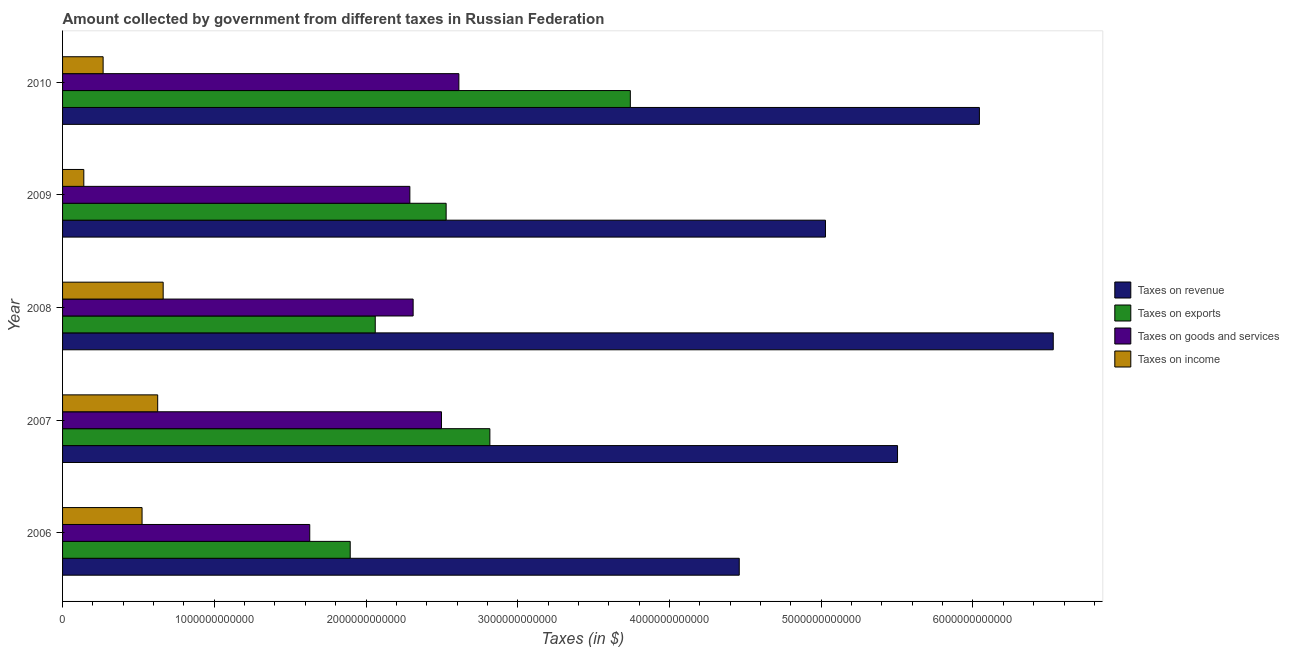How many bars are there on the 2nd tick from the top?
Provide a short and direct response. 4. In how many cases, is the number of bars for a given year not equal to the number of legend labels?
Make the answer very short. 0. What is the amount collected as tax on goods in 2009?
Make the answer very short. 2.29e+12. Across all years, what is the maximum amount collected as tax on income?
Your answer should be compact. 6.63e+11. Across all years, what is the minimum amount collected as tax on revenue?
Provide a short and direct response. 4.46e+12. In which year was the amount collected as tax on income maximum?
Offer a very short reply. 2008. In which year was the amount collected as tax on income minimum?
Your answer should be compact. 2009. What is the total amount collected as tax on revenue in the graph?
Your answer should be very brief. 2.76e+13. What is the difference between the amount collected as tax on exports in 2006 and that in 2010?
Your answer should be very brief. -1.85e+12. What is the difference between the amount collected as tax on exports in 2009 and the amount collected as tax on revenue in 2008?
Offer a very short reply. -4.00e+12. What is the average amount collected as tax on goods per year?
Your answer should be compact. 2.27e+12. In the year 2008, what is the difference between the amount collected as tax on exports and amount collected as tax on income?
Ensure brevity in your answer.  1.40e+12. In how many years, is the amount collected as tax on exports greater than 5600000000000 $?
Provide a short and direct response. 0. What is the ratio of the amount collected as tax on goods in 2007 to that in 2010?
Make the answer very short. 0.96. Is the amount collected as tax on revenue in 2007 less than that in 2010?
Ensure brevity in your answer.  Yes. Is the difference between the amount collected as tax on goods in 2008 and 2010 greater than the difference between the amount collected as tax on exports in 2008 and 2010?
Provide a succinct answer. Yes. What is the difference between the highest and the second highest amount collected as tax on revenue?
Your response must be concise. 4.87e+11. What is the difference between the highest and the lowest amount collected as tax on goods?
Your answer should be very brief. 9.83e+11. What does the 3rd bar from the top in 2007 represents?
Your response must be concise. Taxes on exports. What does the 1st bar from the bottom in 2007 represents?
Provide a short and direct response. Taxes on revenue. Is it the case that in every year, the sum of the amount collected as tax on revenue and amount collected as tax on exports is greater than the amount collected as tax on goods?
Ensure brevity in your answer.  Yes. How many bars are there?
Keep it short and to the point. 20. Are all the bars in the graph horizontal?
Your answer should be compact. Yes. How many years are there in the graph?
Offer a terse response. 5. What is the difference between two consecutive major ticks on the X-axis?
Your answer should be very brief. 1.00e+12. Does the graph contain any zero values?
Offer a terse response. No. Where does the legend appear in the graph?
Give a very brief answer. Center right. What is the title of the graph?
Offer a very short reply. Amount collected by government from different taxes in Russian Federation. Does "Luxembourg" appear as one of the legend labels in the graph?
Your response must be concise. No. What is the label or title of the X-axis?
Provide a short and direct response. Taxes (in $). What is the label or title of the Y-axis?
Your answer should be very brief. Year. What is the Taxes (in $) in Taxes on revenue in 2006?
Provide a short and direct response. 4.46e+12. What is the Taxes (in $) in Taxes on exports in 2006?
Ensure brevity in your answer.  1.90e+12. What is the Taxes (in $) in Taxes on goods and services in 2006?
Keep it short and to the point. 1.63e+12. What is the Taxes (in $) of Taxes on income in 2006?
Keep it short and to the point. 5.24e+11. What is the Taxes (in $) of Taxes on revenue in 2007?
Provide a short and direct response. 5.50e+12. What is the Taxes (in $) of Taxes on exports in 2007?
Your answer should be compact. 2.82e+12. What is the Taxes (in $) in Taxes on goods and services in 2007?
Your response must be concise. 2.50e+12. What is the Taxes (in $) of Taxes on income in 2007?
Give a very brief answer. 6.27e+11. What is the Taxes (in $) in Taxes on revenue in 2008?
Ensure brevity in your answer.  6.53e+12. What is the Taxes (in $) in Taxes on exports in 2008?
Offer a terse response. 2.06e+12. What is the Taxes (in $) in Taxes on goods and services in 2008?
Keep it short and to the point. 2.31e+12. What is the Taxes (in $) in Taxes on income in 2008?
Your response must be concise. 6.63e+11. What is the Taxes (in $) in Taxes on revenue in 2009?
Offer a very short reply. 5.03e+12. What is the Taxes (in $) in Taxes on exports in 2009?
Keep it short and to the point. 2.53e+12. What is the Taxes (in $) of Taxes on goods and services in 2009?
Provide a succinct answer. 2.29e+12. What is the Taxes (in $) of Taxes on income in 2009?
Provide a short and direct response. 1.40e+11. What is the Taxes (in $) in Taxes on revenue in 2010?
Your response must be concise. 6.04e+12. What is the Taxes (in $) of Taxes on exports in 2010?
Offer a terse response. 3.74e+12. What is the Taxes (in $) of Taxes on goods and services in 2010?
Your response must be concise. 2.61e+12. What is the Taxes (in $) in Taxes on income in 2010?
Your response must be concise. 2.67e+11. Across all years, what is the maximum Taxes (in $) of Taxes on revenue?
Offer a terse response. 6.53e+12. Across all years, what is the maximum Taxes (in $) in Taxes on exports?
Make the answer very short. 3.74e+12. Across all years, what is the maximum Taxes (in $) in Taxes on goods and services?
Ensure brevity in your answer.  2.61e+12. Across all years, what is the maximum Taxes (in $) in Taxes on income?
Your answer should be very brief. 6.63e+11. Across all years, what is the minimum Taxes (in $) in Taxes on revenue?
Provide a short and direct response. 4.46e+12. Across all years, what is the minimum Taxes (in $) in Taxes on exports?
Provide a succinct answer. 1.90e+12. Across all years, what is the minimum Taxes (in $) in Taxes on goods and services?
Provide a short and direct response. 1.63e+12. Across all years, what is the minimum Taxes (in $) in Taxes on income?
Make the answer very short. 1.40e+11. What is the total Taxes (in $) of Taxes on revenue in the graph?
Give a very brief answer. 2.76e+13. What is the total Taxes (in $) in Taxes on exports in the graph?
Ensure brevity in your answer.  1.30e+13. What is the total Taxes (in $) in Taxes on goods and services in the graph?
Keep it short and to the point. 1.13e+13. What is the total Taxes (in $) of Taxes on income in the graph?
Your answer should be compact. 2.22e+12. What is the difference between the Taxes (in $) of Taxes on revenue in 2006 and that in 2007?
Make the answer very short. -1.04e+12. What is the difference between the Taxes (in $) of Taxes on exports in 2006 and that in 2007?
Give a very brief answer. -9.20e+11. What is the difference between the Taxes (in $) in Taxes on goods and services in 2006 and that in 2007?
Give a very brief answer. -8.68e+11. What is the difference between the Taxes (in $) in Taxes on income in 2006 and that in 2007?
Your answer should be very brief. -1.03e+11. What is the difference between the Taxes (in $) of Taxes on revenue in 2006 and that in 2008?
Make the answer very short. -2.07e+12. What is the difference between the Taxes (in $) of Taxes on exports in 2006 and that in 2008?
Provide a short and direct response. -1.65e+11. What is the difference between the Taxes (in $) in Taxes on goods and services in 2006 and that in 2008?
Make the answer very short. -6.81e+11. What is the difference between the Taxes (in $) of Taxes on income in 2006 and that in 2008?
Provide a short and direct response. -1.39e+11. What is the difference between the Taxes (in $) of Taxes on revenue in 2006 and that in 2009?
Your answer should be compact. -5.68e+11. What is the difference between the Taxes (in $) in Taxes on exports in 2006 and that in 2009?
Your answer should be very brief. -6.32e+11. What is the difference between the Taxes (in $) in Taxes on goods and services in 2006 and that in 2009?
Keep it short and to the point. -6.60e+11. What is the difference between the Taxes (in $) of Taxes on income in 2006 and that in 2009?
Give a very brief answer. 3.84e+11. What is the difference between the Taxes (in $) in Taxes on revenue in 2006 and that in 2010?
Provide a succinct answer. -1.58e+12. What is the difference between the Taxes (in $) in Taxes on exports in 2006 and that in 2010?
Give a very brief answer. -1.85e+12. What is the difference between the Taxes (in $) of Taxes on goods and services in 2006 and that in 2010?
Offer a terse response. -9.83e+11. What is the difference between the Taxes (in $) in Taxes on income in 2006 and that in 2010?
Your answer should be very brief. 2.57e+11. What is the difference between the Taxes (in $) in Taxes on revenue in 2007 and that in 2008?
Provide a succinct answer. -1.03e+12. What is the difference between the Taxes (in $) of Taxes on exports in 2007 and that in 2008?
Keep it short and to the point. 7.55e+11. What is the difference between the Taxes (in $) in Taxes on goods and services in 2007 and that in 2008?
Your answer should be compact. 1.87e+11. What is the difference between the Taxes (in $) of Taxes on income in 2007 and that in 2008?
Provide a short and direct response. -3.62e+1. What is the difference between the Taxes (in $) of Taxes on revenue in 2007 and that in 2009?
Ensure brevity in your answer.  4.75e+11. What is the difference between the Taxes (in $) of Taxes on exports in 2007 and that in 2009?
Your answer should be compact. 2.88e+11. What is the difference between the Taxes (in $) in Taxes on goods and services in 2007 and that in 2009?
Offer a terse response. 2.08e+11. What is the difference between the Taxes (in $) in Taxes on income in 2007 and that in 2009?
Provide a succinct answer. 4.87e+11. What is the difference between the Taxes (in $) of Taxes on revenue in 2007 and that in 2010?
Your answer should be very brief. -5.40e+11. What is the difference between the Taxes (in $) of Taxes on exports in 2007 and that in 2010?
Offer a very short reply. -9.26e+11. What is the difference between the Taxes (in $) in Taxes on goods and services in 2007 and that in 2010?
Make the answer very short. -1.15e+11. What is the difference between the Taxes (in $) in Taxes on income in 2007 and that in 2010?
Offer a terse response. 3.60e+11. What is the difference between the Taxes (in $) of Taxes on revenue in 2008 and that in 2009?
Your response must be concise. 1.50e+12. What is the difference between the Taxes (in $) of Taxes on exports in 2008 and that in 2009?
Your response must be concise. -4.67e+11. What is the difference between the Taxes (in $) in Taxes on goods and services in 2008 and that in 2009?
Provide a short and direct response. 2.16e+1. What is the difference between the Taxes (in $) in Taxes on income in 2008 and that in 2009?
Give a very brief answer. 5.23e+11. What is the difference between the Taxes (in $) of Taxes on revenue in 2008 and that in 2010?
Your answer should be compact. 4.87e+11. What is the difference between the Taxes (in $) of Taxes on exports in 2008 and that in 2010?
Offer a very short reply. -1.68e+12. What is the difference between the Taxes (in $) of Taxes on goods and services in 2008 and that in 2010?
Offer a terse response. -3.01e+11. What is the difference between the Taxes (in $) in Taxes on income in 2008 and that in 2010?
Give a very brief answer. 3.96e+11. What is the difference between the Taxes (in $) of Taxes on revenue in 2009 and that in 2010?
Keep it short and to the point. -1.01e+12. What is the difference between the Taxes (in $) of Taxes on exports in 2009 and that in 2010?
Your answer should be compact. -1.21e+12. What is the difference between the Taxes (in $) of Taxes on goods and services in 2009 and that in 2010?
Give a very brief answer. -3.23e+11. What is the difference between the Taxes (in $) in Taxes on income in 2009 and that in 2010?
Provide a succinct answer. -1.27e+11. What is the difference between the Taxes (in $) of Taxes on revenue in 2006 and the Taxes (in $) of Taxes on exports in 2007?
Make the answer very short. 1.64e+12. What is the difference between the Taxes (in $) in Taxes on revenue in 2006 and the Taxes (in $) in Taxes on goods and services in 2007?
Provide a succinct answer. 1.96e+12. What is the difference between the Taxes (in $) of Taxes on revenue in 2006 and the Taxes (in $) of Taxes on income in 2007?
Your answer should be compact. 3.83e+12. What is the difference between the Taxes (in $) of Taxes on exports in 2006 and the Taxes (in $) of Taxes on goods and services in 2007?
Offer a terse response. -6.02e+11. What is the difference between the Taxes (in $) of Taxes on exports in 2006 and the Taxes (in $) of Taxes on income in 2007?
Your answer should be very brief. 1.27e+12. What is the difference between the Taxes (in $) of Taxes on goods and services in 2006 and the Taxes (in $) of Taxes on income in 2007?
Provide a succinct answer. 1.00e+12. What is the difference between the Taxes (in $) in Taxes on revenue in 2006 and the Taxes (in $) in Taxes on exports in 2008?
Keep it short and to the point. 2.40e+12. What is the difference between the Taxes (in $) of Taxes on revenue in 2006 and the Taxes (in $) of Taxes on goods and services in 2008?
Offer a terse response. 2.15e+12. What is the difference between the Taxes (in $) in Taxes on revenue in 2006 and the Taxes (in $) in Taxes on income in 2008?
Offer a terse response. 3.80e+12. What is the difference between the Taxes (in $) in Taxes on exports in 2006 and the Taxes (in $) in Taxes on goods and services in 2008?
Offer a very short reply. -4.15e+11. What is the difference between the Taxes (in $) in Taxes on exports in 2006 and the Taxes (in $) in Taxes on income in 2008?
Give a very brief answer. 1.23e+12. What is the difference between the Taxes (in $) in Taxes on goods and services in 2006 and the Taxes (in $) in Taxes on income in 2008?
Give a very brief answer. 9.66e+11. What is the difference between the Taxes (in $) in Taxes on revenue in 2006 and the Taxes (in $) in Taxes on exports in 2009?
Offer a very short reply. 1.93e+12. What is the difference between the Taxes (in $) in Taxes on revenue in 2006 and the Taxes (in $) in Taxes on goods and services in 2009?
Provide a short and direct response. 2.17e+12. What is the difference between the Taxes (in $) of Taxes on revenue in 2006 and the Taxes (in $) of Taxes on income in 2009?
Offer a very short reply. 4.32e+12. What is the difference between the Taxes (in $) of Taxes on exports in 2006 and the Taxes (in $) of Taxes on goods and services in 2009?
Keep it short and to the point. -3.93e+11. What is the difference between the Taxes (in $) in Taxes on exports in 2006 and the Taxes (in $) in Taxes on income in 2009?
Your answer should be compact. 1.76e+12. What is the difference between the Taxes (in $) in Taxes on goods and services in 2006 and the Taxes (in $) in Taxes on income in 2009?
Offer a very short reply. 1.49e+12. What is the difference between the Taxes (in $) of Taxes on revenue in 2006 and the Taxes (in $) of Taxes on exports in 2010?
Your answer should be compact. 7.18e+11. What is the difference between the Taxes (in $) in Taxes on revenue in 2006 and the Taxes (in $) in Taxes on goods and services in 2010?
Provide a short and direct response. 1.85e+12. What is the difference between the Taxes (in $) of Taxes on revenue in 2006 and the Taxes (in $) of Taxes on income in 2010?
Offer a very short reply. 4.19e+12. What is the difference between the Taxes (in $) of Taxes on exports in 2006 and the Taxes (in $) of Taxes on goods and services in 2010?
Offer a terse response. -7.16e+11. What is the difference between the Taxes (in $) in Taxes on exports in 2006 and the Taxes (in $) in Taxes on income in 2010?
Offer a very short reply. 1.63e+12. What is the difference between the Taxes (in $) of Taxes on goods and services in 2006 and the Taxes (in $) of Taxes on income in 2010?
Your answer should be compact. 1.36e+12. What is the difference between the Taxes (in $) of Taxes on revenue in 2007 and the Taxes (in $) of Taxes on exports in 2008?
Make the answer very short. 3.44e+12. What is the difference between the Taxes (in $) in Taxes on revenue in 2007 and the Taxes (in $) in Taxes on goods and services in 2008?
Your response must be concise. 3.19e+12. What is the difference between the Taxes (in $) in Taxes on revenue in 2007 and the Taxes (in $) in Taxes on income in 2008?
Provide a succinct answer. 4.84e+12. What is the difference between the Taxes (in $) in Taxes on exports in 2007 and the Taxes (in $) in Taxes on goods and services in 2008?
Your answer should be very brief. 5.06e+11. What is the difference between the Taxes (in $) in Taxes on exports in 2007 and the Taxes (in $) in Taxes on income in 2008?
Provide a short and direct response. 2.15e+12. What is the difference between the Taxes (in $) in Taxes on goods and services in 2007 and the Taxes (in $) in Taxes on income in 2008?
Offer a terse response. 1.83e+12. What is the difference between the Taxes (in $) of Taxes on revenue in 2007 and the Taxes (in $) of Taxes on exports in 2009?
Ensure brevity in your answer.  2.97e+12. What is the difference between the Taxes (in $) in Taxes on revenue in 2007 and the Taxes (in $) in Taxes on goods and services in 2009?
Your answer should be compact. 3.21e+12. What is the difference between the Taxes (in $) in Taxes on revenue in 2007 and the Taxes (in $) in Taxes on income in 2009?
Your answer should be very brief. 5.36e+12. What is the difference between the Taxes (in $) of Taxes on exports in 2007 and the Taxes (in $) of Taxes on goods and services in 2009?
Provide a succinct answer. 5.27e+11. What is the difference between the Taxes (in $) in Taxes on exports in 2007 and the Taxes (in $) in Taxes on income in 2009?
Give a very brief answer. 2.68e+12. What is the difference between the Taxes (in $) of Taxes on goods and services in 2007 and the Taxes (in $) of Taxes on income in 2009?
Your response must be concise. 2.36e+12. What is the difference between the Taxes (in $) of Taxes on revenue in 2007 and the Taxes (in $) of Taxes on exports in 2010?
Your answer should be compact. 1.76e+12. What is the difference between the Taxes (in $) of Taxes on revenue in 2007 and the Taxes (in $) of Taxes on goods and services in 2010?
Offer a terse response. 2.89e+12. What is the difference between the Taxes (in $) of Taxes on revenue in 2007 and the Taxes (in $) of Taxes on income in 2010?
Ensure brevity in your answer.  5.24e+12. What is the difference between the Taxes (in $) in Taxes on exports in 2007 and the Taxes (in $) in Taxes on goods and services in 2010?
Offer a very short reply. 2.04e+11. What is the difference between the Taxes (in $) of Taxes on exports in 2007 and the Taxes (in $) of Taxes on income in 2010?
Give a very brief answer. 2.55e+12. What is the difference between the Taxes (in $) in Taxes on goods and services in 2007 and the Taxes (in $) in Taxes on income in 2010?
Provide a succinct answer. 2.23e+12. What is the difference between the Taxes (in $) in Taxes on revenue in 2008 and the Taxes (in $) in Taxes on exports in 2009?
Provide a short and direct response. 4.00e+12. What is the difference between the Taxes (in $) in Taxes on revenue in 2008 and the Taxes (in $) in Taxes on goods and services in 2009?
Make the answer very short. 4.24e+12. What is the difference between the Taxes (in $) of Taxes on revenue in 2008 and the Taxes (in $) of Taxes on income in 2009?
Make the answer very short. 6.39e+12. What is the difference between the Taxes (in $) of Taxes on exports in 2008 and the Taxes (in $) of Taxes on goods and services in 2009?
Provide a short and direct response. -2.28e+11. What is the difference between the Taxes (in $) of Taxes on exports in 2008 and the Taxes (in $) of Taxes on income in 2009?
Offer a very short reply. 1.92e+12. What is the difference between the Taxes (in $) of Taxes on goods and services in 2008 and the Taxes (in $) of Taxes on income in 2009?
Provide a short and direct response. 2.17e+12. What is the difference between the Taxes (in $) of Taxes on revenue in 2008 and the Taxes (in $) of Taxes on exports in 2010?
Offer a very short reply. 2.79e+12. What is the difference between the Taxes (in $) of Taxes on revenue in 2008 and the Taxes (in $) of Taxes on goods and services in 2010?
Give a very brief answer. 3.92e+12. What is the difference between the Taxes (in $) of Taxes on revenue in 2008 and the Taxes (in $) of Taxes on income in 2010?
Ensure brevity in your answer.  6.26e+12. What is the difference between the Taxes (in $) of Taxes on exports in 2008 and the Taxes (in $) of Taxes on goods and services in 2010?
Ensure brevity in your answer.  -5.51e+11. What is the difference between the Taxes (in $) in Taxes on exports in 2008 and the Taxes (in $) in Taxes on income in 2010?
Provide a succinct answer. 1.79e+12. What is the difference between the Taxes (in $) of Taxes on goods and services in 2008 and the Taxes (in $) of Taxes on income in 2010?
Keep it short and to the point. 2.04e+12. What is the difference between the Taxes (in $) of Taxes on revenue in 2009 and the Taxes (in $) of Taxes on exports in 2010?
Keep it short and to the point. 1.29e+12. What is the difference between the Taxes (in $) of Taxes on revenue in 2009 and the Taxes (in $) of Taxes on goods and services in 2010?
Keep it short and to the point. 2.42e+12. What is the difference between the Taxes (in $) in Taxes on revenue in 2009 and the Taxes (in $) in Taxes on income in 2010?
Give a very brief answer. 4.76e+12. What is the difference between the Taxes (in $) in Taxes on exports in 2009 and the Taxes (in $) in Taxes on goods and services in 2010?
Provide a short and direct response. -8.39e+1. What is the difference between the Taxes (in $) of Taxes on exports in 2009 and the Taxes (in $) of Taxes on income in 2010?
Your answer should be very brief. 2.26e+12. What is the difference between the Taxes (in $) in Taxes on goods and services in 2009 and the Taxes (in $) in Taxes on income in 2010?
Keep it short and to the point. 2.02e+12. What is the average Taxes (in $) of Taxes on revenue per year?
Ensure brevity in your answer.  5.51e+12. What is the average Taxes (in $) of Taxes on exports per year?
Your answer should be compact. 2.61e+12. What is the average Taxes (in $) of Taxes on goods and services per year?
Give a very brief answer. 2.27e+12. What is the average Taxes (in $) of Taxes on income per year?
Make the answer very short. 4.44e+11. In the year 2006, what is the difference between the Taxes (in $) in Taxes on revenue and Taxes (in $) in Taxes on exports?
Ensure brevity in your answer.  2.56e+12. In the year 2006, what is the difference between the Taxes (in $) in Taxes on revenue and Taxes (in $) in Taxes on goods and services?
Give a very brief answer. 2.83e+12. In the year 2006, what is the difference between the Taxes (in $) in Taxes on revenue and Taxes (in $) in Taxes on income?
Give a very brief answer. 3.94e+12. In the year 2006, what is the difference between the Taxes (in $) in Taxes on exports and Taxes (in $) in Taxes on goods and services?
Your response must be concise. 2.67e+11. In the year 2006, what is the difference between the Taxes (in $) of Taxes on exports and Taxes (in $) of Taxes on income?
Offer a terse response. 1.37e+12. In the year 2006, what is the difference between the Taxes (in $) of Taxes on goods and services and Taxes (in $) of Taxes on income?
Keep it short and to the point. 1.11e+12. In the year 2007, what is the difference between the Taxes (in $) of Taxes on revenue and Taxes (in $) of Taxes on exports?
Ensure brevity in your answer.  2.69e+12. In the year 2007, what is the difference between the Taxes (in $) in Taxes on revenue and Taxes (in $) in Taxes on goods and services?
Make the answer very short. 3.01e+12. In the year 2007, what is the difference between the Taxes (in $) in Taxes on revenue and Taxes (in $) in Taxes on income?
Your response must be concise. 4.88e+12. In the year 2007, what is the difference between the Taxes (in $) in Taxes on exports and Taxes (in $) in Taxes on goods and services?
Provide a short and direct response. 3.19e+11. In the year 2007, what is the difference between the Taxes (in $) of Taxes on exports and Taxes (in $) of Taxes on income?
Make the answer very short. 2.19e+12. In the year 2007, what is the difference between the Taxes (in $) in Taxes on goods and services and Taxes (in $) in Taxes on income?
Keep it short and to the point. 1.87e+12. In the year 2008, what is the difference between the Taxes (in $) of Taxes on revenue and Taxes (in $) of Taxes on exports?
Offer a terse response. 4.47e+12. In the year 2008, what is the difference between the Taxes (in $) in Taxes on revenue and Taxes (in $) in Taxes on goods and services?
Offer a terse response. 4.22e+12. In the year 2008, what is the difference between the Taxes (in $) of Taxes on revenue and Taxes (in $) of Taxes on income?
Ensure brevity in your answer.  5.87e+12. In the year 2008, what is the difference between the Taxes (in $) in Taxes on exports and Taxes (in $) in Taxes on goods and services?
Ensure brevity in your answer.  -2.50e+11. In the year 2008, what is the difference between the Taxes (in $) of Taxes on exports and Taxes (in $) of Taxes on income?
Ensure brevity in your answer.  1.40e+12. In the year 2008, what is the difference between the Taxes (in $) in Taxes on goods and services and Taxes (in $) in Taxes on income?
Offer a very short reply. 1.65e+12. In the year 2009, what is the difference between the Taxes (in $) in Taxes on revenue and Taxes (in $) in Taxes on exports?
Ensure brevity in your answer.  2.50e+12. In the year 2009, what is the difference between the Taxes (in $) of Taxes on revenue and Taxes (in $) of Taxes on goods and services?
Offer a terse response. 2.74e+12. In the year 2009, what is the difference between the Taxes (in $) in Taxes on revenue and Taxes (in $) in Taxes on income?
Make the answer very short. 4.89e+12. In the year 2009, what is the difference between the Taxes (in $) of Taxes on exports and Taxes (in $) of Taxes on goods and services?
Ensure brevity in your answer.  2.39e+11. In the year 2009, what is the difference between the Taxes (in $) in Taxes on exports and Taxes (in $) in Taxes on income?
Make the answer very short. 2.39e+12. In the year 2009, what is the difference between the Taxes (in $) of Taxes on goods and services and Taxes (in $) of Taxes on income?
Your response must be concise. 2.15e+12. In the year 2010, what is the difference between the Taxes (in $) in Taxes on revenue and Taxes (in $) in Taxes on exports?
Offer a very short reply. 2.30e+12. In the year 2010, what is the difference between the Taxes (in $) of Taxes on revenue and Taxes (in $) of Taxes on goods and services?
Your answer should be very brief. 3.43e+12. In the year 2010, what is the difference between the Taxes (in $) of Taxes on revenue and Taxes (in $) of Taxes on income?
Your answer should be very brief. 5.78e+12. In the year 2010, what is the difference between the Taxes (in $) of Taxes on exports and Taxes (in $) of Taxes on goods and services?
Keep it short and to the point. 1.13e+12. In the year 2010, what is the difference between the Taxes (in $) of Taxes on exports and Taxes (in $) of Taxes on income?
Ensure brevity in your answer.  3.47e+12. In the year 2010, what is the difference between the Taxes (in $) of Taxes on goods and services and Taxes (in $) of Taxes on income?
Ensure brevity in your answer.  2.34e+12. What is the ratio of the Taxes (in $) of Taxes on revenue in 2006 to that in 2007?
Your answer should be compact. 0.81. What is the ratio of the Taxes (in $) in Taxes on exports in 2006 to that in 2007?
Your response must be concise. 0.67. What is the ratio of the Taxes (in $) in Taxes on goods and services in 2006 to that in 2007?
Offer a terse response. 0.65. What is the ratio of the Taxes (in $) in Taxes on income in 2006 to that in 2007?
Offer a terse response. 0.84. What is the ratio of the Taxes (in $) of Taxes on revenue in 2006 to that in 2008?
Provide a succinct answer. 0.68. What is the ratio of the Taxes (in $) of Taxes on exports in 2006 to that in 2008?
Offer a very short reply. 0.92. What is the ratio of the Taxes (in $) of Taxes on goods and services in 2006 to that in 2008?
Give a very brief answer. 0.71. What is the ratio of the Taxes (in $) in Taxes on income in 2006 to that in 2008?
Ensure brevity in your answer.  0.79. What is the ratio of the Taxes (in $) of Taxes on revenue in 2006 to that in 2009?
Your answer should be very brief. 0.89. What is the ratio of the Taxes (in $) of Taxes on exports in 2006 to that in 2009?
Offer a very short reply. 0.75. What is the ratio of the Taxes (in $) of Taxes on goods and services in 2006 to that in 2009?
Provide a succinct answer. 0.71. What is the ratio of the Taxes (in $) of Taxes on income in 2006 to that in 2009?
Give a very brief answer. 3.74. What is the ratio of the Taxes (in $) in Taxes on revenue in 2006 to that in 2010?
Keep it short and to the point. 0.74. What is the ratio of the Taxes (in $) in Taxes on exports in 2006 to that in 2010?
Ensure brevity in your answer.  0.51. What is the ratio of the Taxes (in $) of Taxes on goods and services in 2006 to that in 2010?
Give a very brief answer. 0.62. What is the ratio of the Taxes (in $) of Taxes on income in 2006 to that in 2010?
Offer a terse response. 1.96. What is the ratio of the Taxes (in $) in Taxes on revenue in 2007 to that in 2008?
Offer a very short reply. 0.84. What is the ratio of the Taxes (in $) of Taxes on exports in 2007 to that in 2008?
Keep it short and to the point. 1.37. What is the ratio of the Taxes (in $) in Taxes on goods and services in 2007 to that in 2008?
Your answer should be compact. 1.08. What is the ratio of the Taxes (in $) of Taxes on income in 2007 to that in 2008?
Your answer should be very brief. 0.95. What is the ratio of the Taxes (in $) in Taxes on revenue in 2007 to that in 2009?
Make the answer very short. 1.09. What is the ratio of the Taxes (in $) in Taxes on exports in 2007 to that in 2009?
Provide a short and direct response. 1.11. What is the ratio of the Taxes (in $) of Taxes on goods and services in 2007 to that in 2009?
Your answer should be compact. 1.09. What is the ratio of the Taxes (in $) in Taxes on income in 2007 to that in 2009?
Give a very brief answer. 4.48. What is the ratio of the Taxes (in $) in Taxes on revenue in 2007 to that in 2010?
Provide a succinct answer. 0.91. What is the ratio of the Taxes (in $) of Taxes on exports in 2007 to that in 2010?
Provide a succinct answer. 0.75. What is the ratio of the Taxes (in $) of Taxes on goods and services in 2007 to that in 2010?
Your answer should be compact. 0.96. What is the ratio of the Taxes (in $) of Taxes on income in 2007 to that in 2010?
Make the answer very short. 2.35. What is the ratio of the Taxes (in $) in Taxes on revenue in 2008 to that in 2009?
Your answer should be compact. 1.3. What is the ratio of the Taxes (in $) in Taxes on exports in 2008 to that in 2009?
Provide a succinct answer. 0.82. What is the ratio of the Taxes (in $) of Taxes on goods and services in 2008 to that in 2009?
Your answer should be very brief. 1.01. What is the ratio of the Taxes (in $) of Taxes on income in 2008 to that in 2009?
Keep it short and to the point. 4.74. What is the ratio of the Taxes (in $) in Taxes on revenue in 2008 to that in 2010?
Keep it short and to the point. 1.08. What is the ratio of the Taxes (in $) of Taxes on exports in 2008 to that in 2010?
Offer a terse response. 0.55. What is the ratio of the Taxes (in $) of Taxes on goods and services in 2008 to that in 2010?
Your response must be concise. 0.88. What is the ratio of the Taxes (in $) in Taxes on income in 2008 to that in 2010?
Ensure brevity in your answer.  2.48. What is the ratio of the Taxes (in $) in Taxes on revenue in 2009 to that in 2010?
Ensure brevity in your answer.  0.83. What is the ratio of the Taxes (in $) of Taxes on exports in 2009 to that in 2010?
Make the answer very short. 0.68. What is the ratio of the Taxes (in $) in Taxes on goods and services in 2009 to that in 2010?
Your answer should be compact. 0.88. What is the ratio of the Taxes (in $) of Taxes on income in 2009 to that in 2010?
Ensure brevity in your answer.  0.52. What is the difference between the highest and the second highest Taxes (in $) in Taxes on revenue?
Provide a short and direct response. 4.87e+11. What is the difference between the highest and the second highest Taxes (in $) in Taxes on exports?
Your answer should be very brief. 9.26e+11. What is the difference between the highest and the second highest Taxes (in $) in Taxes on goods and services?
Provide a short and direct response. 1.15e+11. What is the difference between the highest and the second highest Taxes (in $) of Taxes on income?
Offer a very short reply. 3.62e+1. What is the difference between the highest and the lowest Taxes (in $) in Taxes on revenue?
Your answer should be compact. 2.07e+12. What is the difference between the highest and the lowest Taxes (in $) in Taxes on exports?
Ensure brevity in your answer.  1.85e+12. What is the difference between the highest and the lowest Taxes (in $) of Taxes on goods and services?
Keep it short and to the point. 9.83e+11. What is the difference between the highest and the lowest Taxes (in $) of Taxes on income?
Make the answer very short. 5.23e+11. 